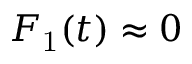<formula> <loc_0><loc_0><loc_500><loc_500>F _ { 1 } ( t ) \approx 0</formula> 